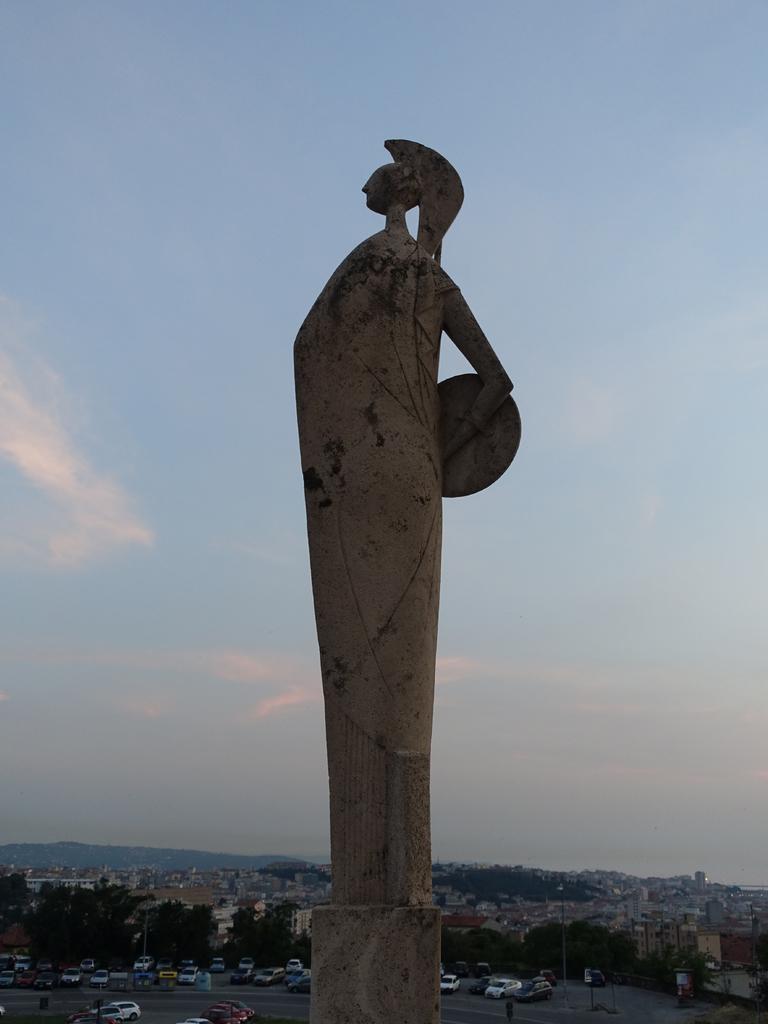Please provide a concise description of this image. This image is taken outdoors. At the top of the image there is a sky with clouds. In the middle of the image there is a statue. At the bottom of the image there are many buildings, houses and trees. A few cars are parked on the road and a few are moving on the road. In the background there are a few hills. 